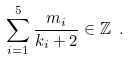Convert formula to latex. <formula><loc_0><loc_0><loc_500><loc_500>\sum _ { i = 1 } ^ { 5 } \frac { m _ { i } } { k _ { i } + 2 } \in \mathbb { Z } \ .</formula> 